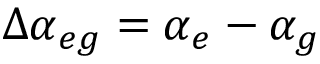<formula> <loc_0><loc_0><loc_500><loc_500>\Delta \alpha _ { e g } = \alpha _ { e } - \alpha _ { g }</formula> 